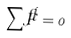Convert formula to latex. <formula><loc_0><loc_0><loc_500><loc_500>\sum { \vec { F } } = 0</formula> 